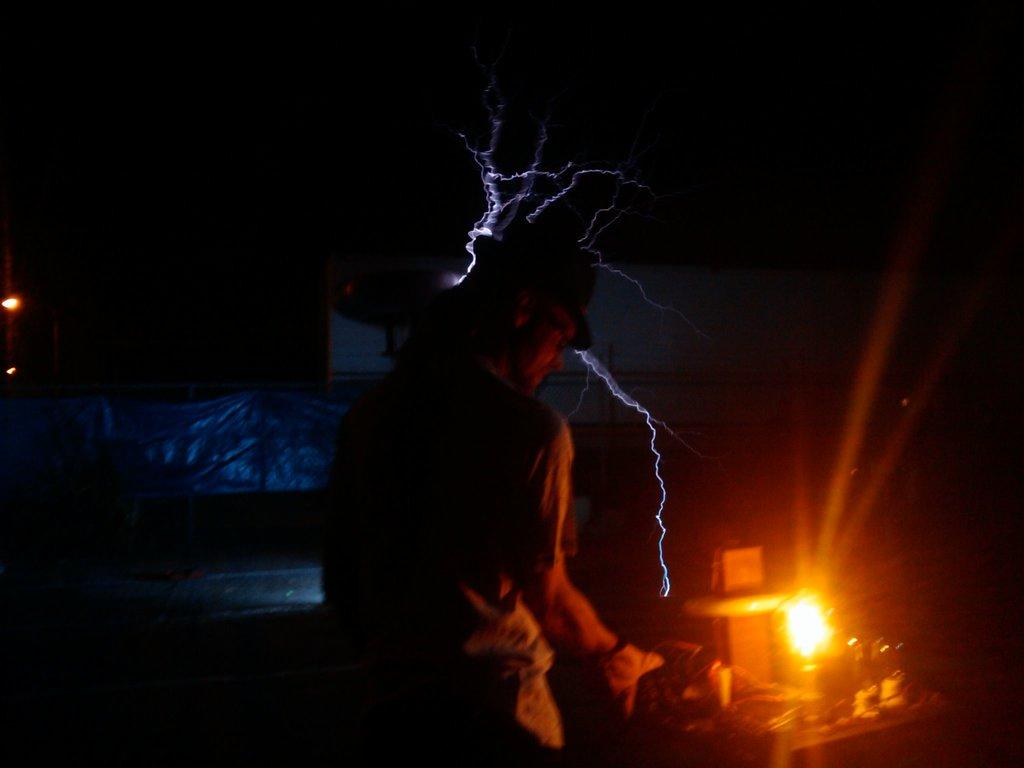Who is the main subject in the image? There is a man in the center of the image. What object can be seen on the right side of the image? There is a lamp on the right side of the image. What structures are visible in the background of the image? There is a tent and a board in the background of the image. Where are the lights located in the image? There are lights on the left side of the image. How many cherries are hanging from the tent in the image? There are no cherries present in the image, and they are not hanging from the tent. 